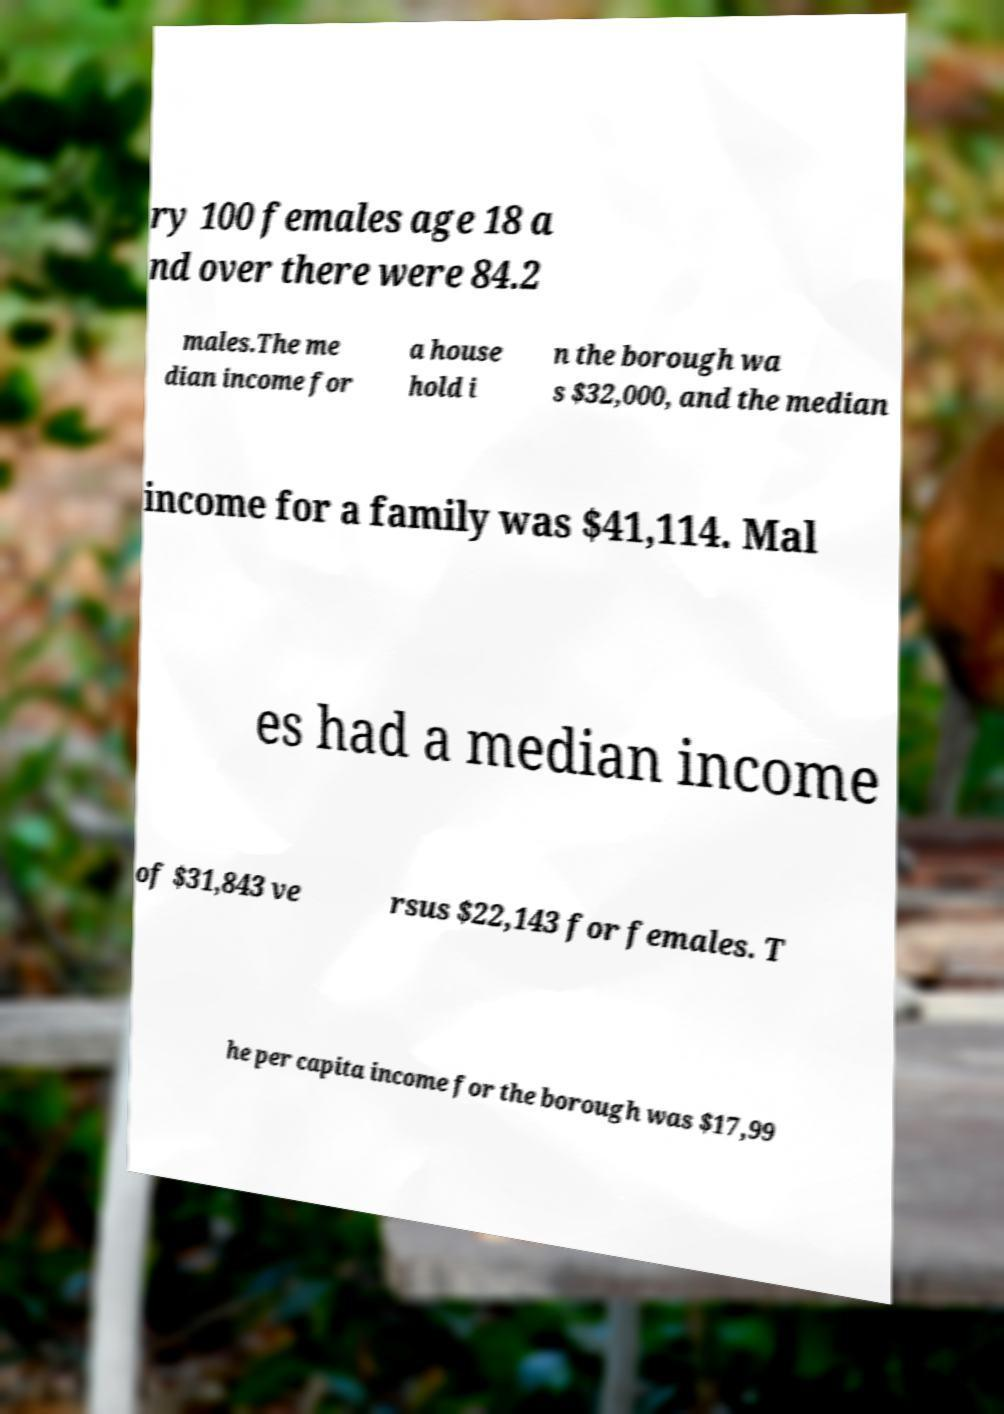Please read and relay the text visible in this image. What does it say? ry 100 females age 18 a nd over there were 84.2 males.The me dian income for a house hold i n the borough wa s $32,000, and the median income for a family was $41,114. Mal es had a median income of $31,843 ve rsus $22,143 for females. T he per capita income for the borough was $17,99 